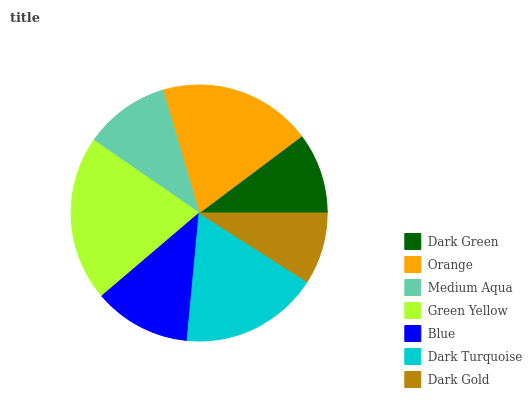Is Dark Gold the minimum?
Answer yes or no. Yes. Is Green Yellow the maximum?
Answer yes or no. Yes. Is Orange the minimum?
Answer yes or no. No. Is Orange the maximum?
Answer yes or no. No. Is Orange greater than Dark Green?
Answer yes or no. Yes. Is Dark Green less than Orange?
Answer yes or no. Yes. Is Dark Green greater than Orange?
Answer yes or no. No. Is Orange less than Dark Green?
Answer yes or no. No. Is Blue the high median?
Answer yes or no. Yes. Is Blue the low median?
Answer yes or no. Yes. Is Dark Turquoise the high median?
Answer yes or no. No. Is Dark Turquoise the low median?
Answer yes or no. No. 